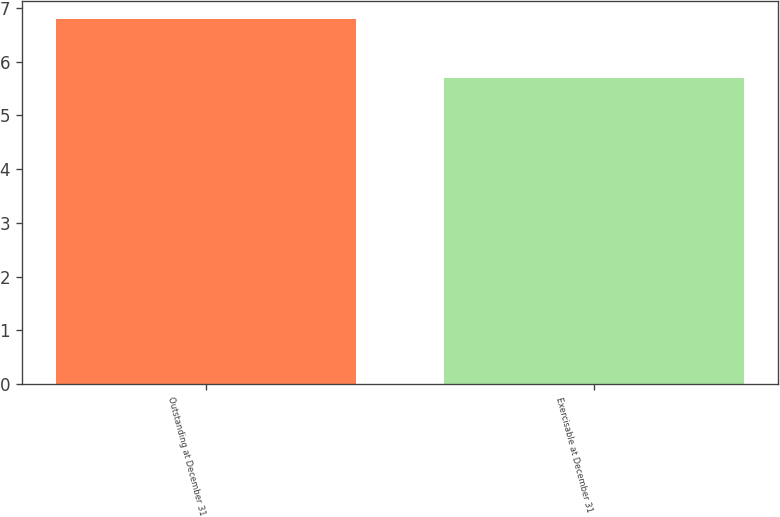Convert chart to OTSL. <chart><loc_0><loc_0><loc_500><loc_500><bar_chart><fcel>Outstanding at December 31<fcel>Exercisable at December 31<nl><fcel>6.8<fcel>5.7<nl></chart> 